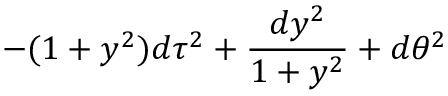<formula> <loc_0><loc_0><loc_500><loc_500>- ( 1 + y ^ { 2 } ) d \tau ^ { 2 } + { \frac { d y ^ { 2 } } { 1 + y ^ { 2 } } } + d \theta ^ { 2 }</formula> 